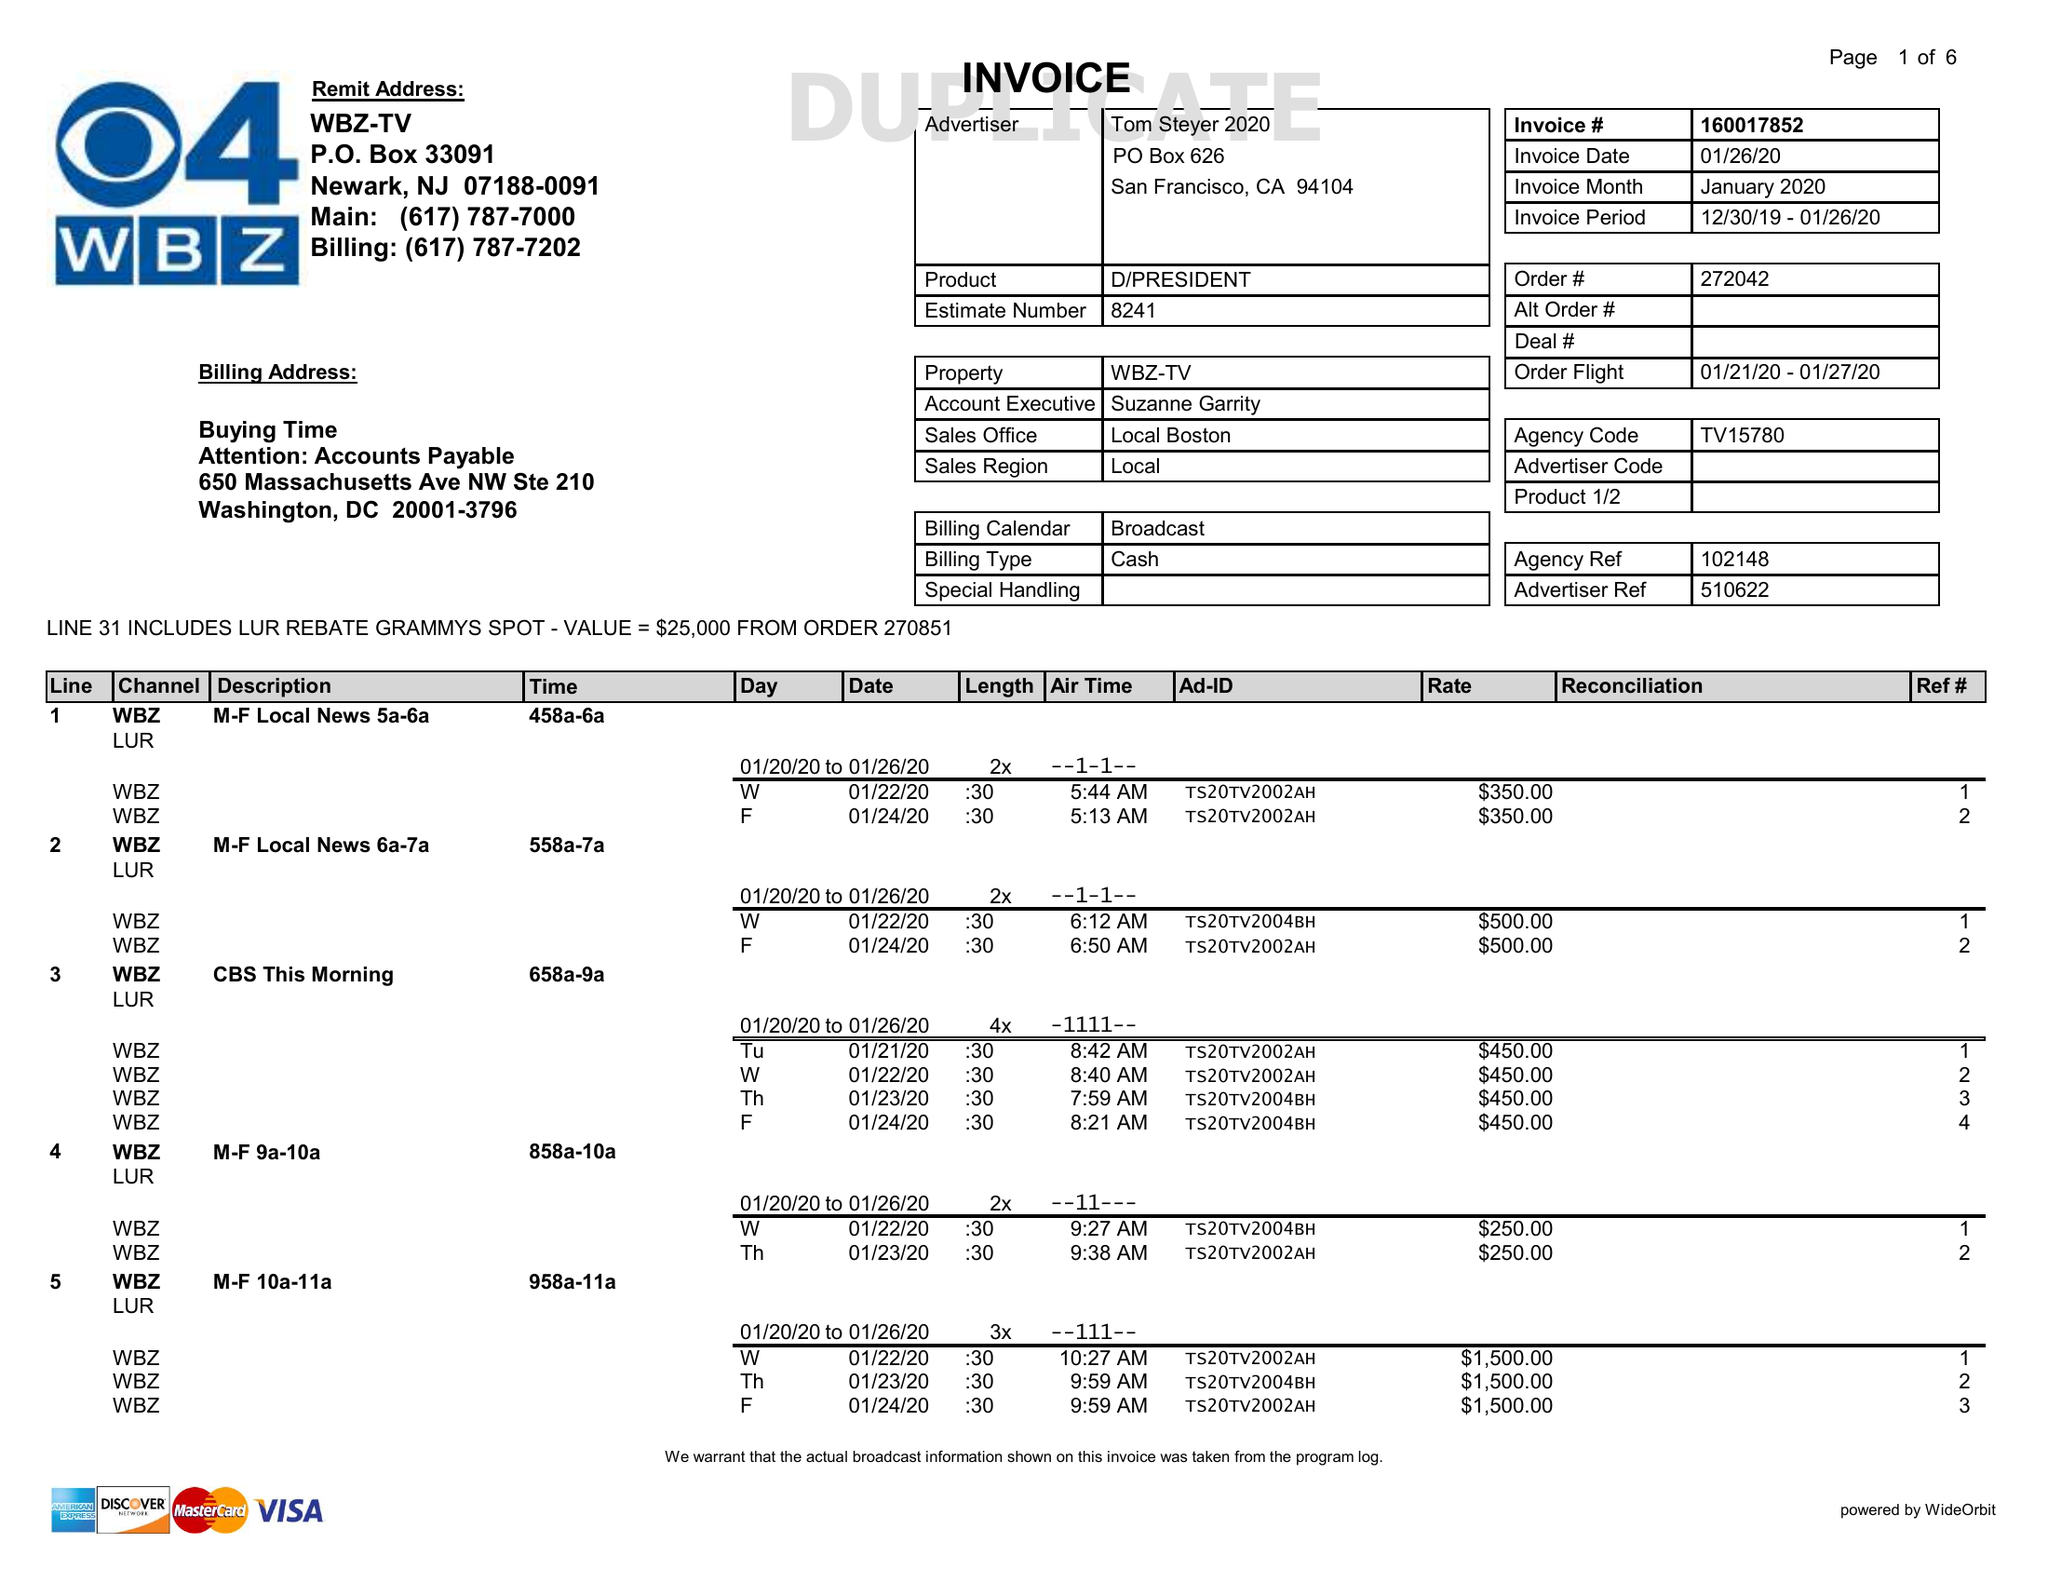What is the value for the gross_amount?
Answer the question using a single word or phrase. 63750.00 